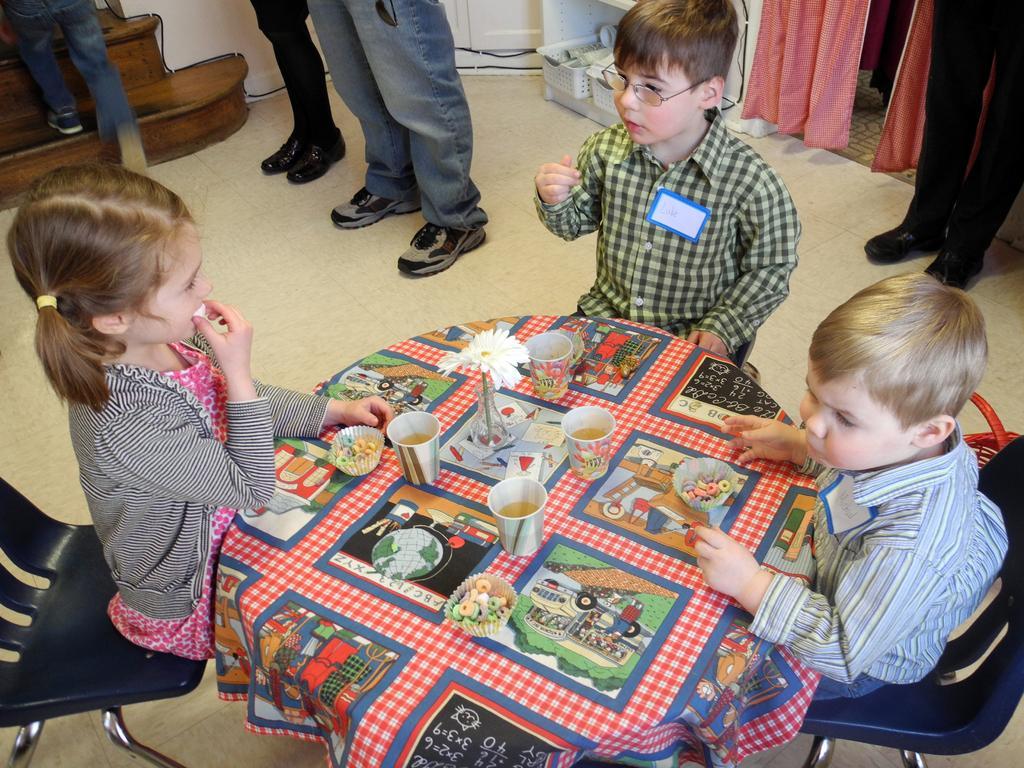Could you give a brief overview of what you see in this image? In this image, there are three kids sitting on the chairs and I can see a table with bowls, glasses and a flower vase. At the top of the image, there are objects in a rack, curtains and I can see the legs of three persons standing on the floor. At the top left corner of the image, I can see the legs of another person climbing the stairs. 